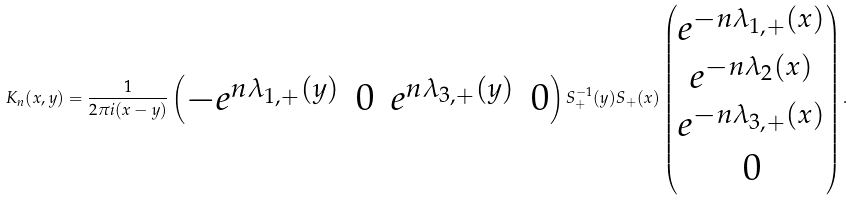Convert formula to latex. <formula><loc_0><loc_0><loc_500><loc_500>K _ { n } ( x , y ) = \frac { 1 } { 2 \pi i ( x - y ) } \begin{pmatrix} - e ^ { n \lambda _ { 1 , + } ( y ) } & 0 & e ^ { n \lambda _ { 3 , + } ( y ) } & 0 \end{pmatrix} S _ { + } ^ { - 1 } ( y ) S _ { + } ( x ) \begin{pmatrix} e ^ { - n \lambda _ { 1 , + } ( x ) } \\ e ^ { - n \lambda _ { 2 } ( x ) } \\ e ^ { - n \lambda _ { 3 , + } ( x ) } \\ 0 \end{pmatrix} .</formula> 